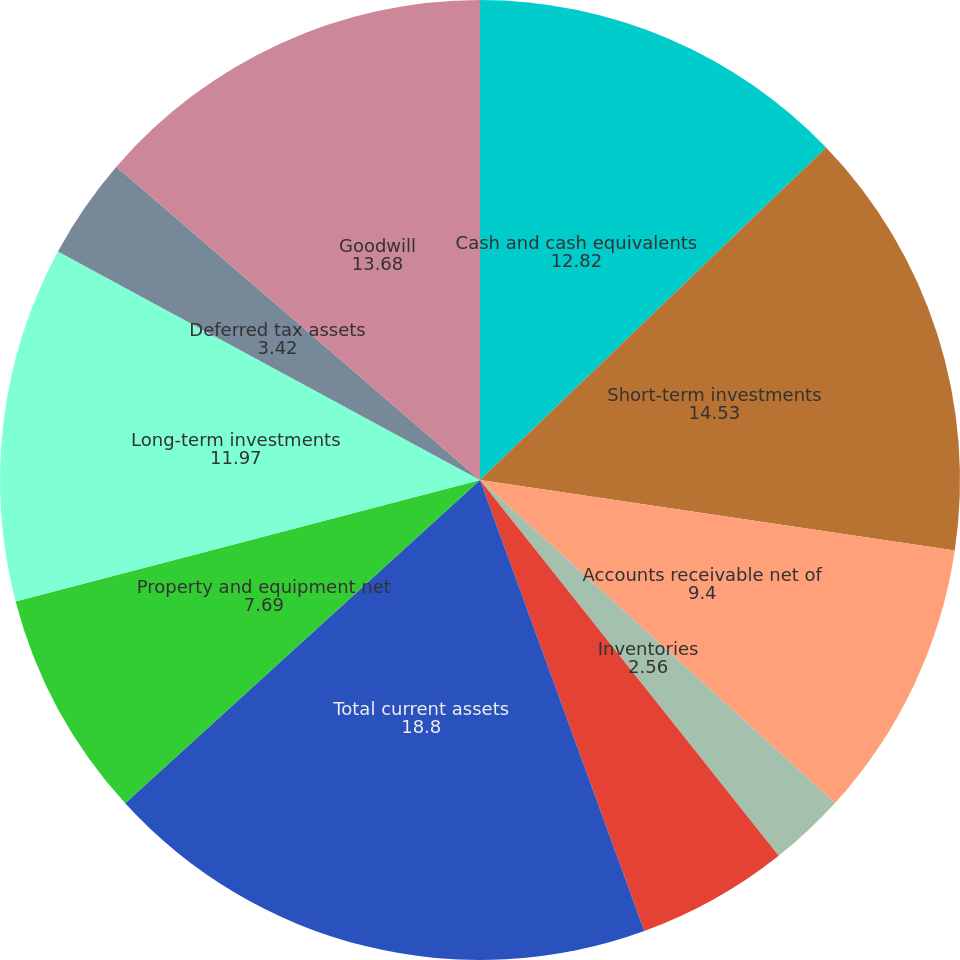Convert chart to OTSL. <chart><loc_0><loc_0><loc_500><loc_500><pie_chart><fcel>Cash and cash equivalents<fcel>Short-term investments<fcel>Accounts receivable net of<fcel>Inventories<fcel>Other current assets<fcel>Total current assets<fcel>Property and equipment net<fcel>Long-term investments<fcel>Deferred tax assets<fcel>Goodwill<nl><fcel>12.82%<fcel>14.53%<fcel>9.4%<fcel>2.56%<fcel>5.13%<fcel>18.8%<fcel>7.69%<fcel>11.97%<fcel>3.42%<fcel>13.68%<nl></chart> 